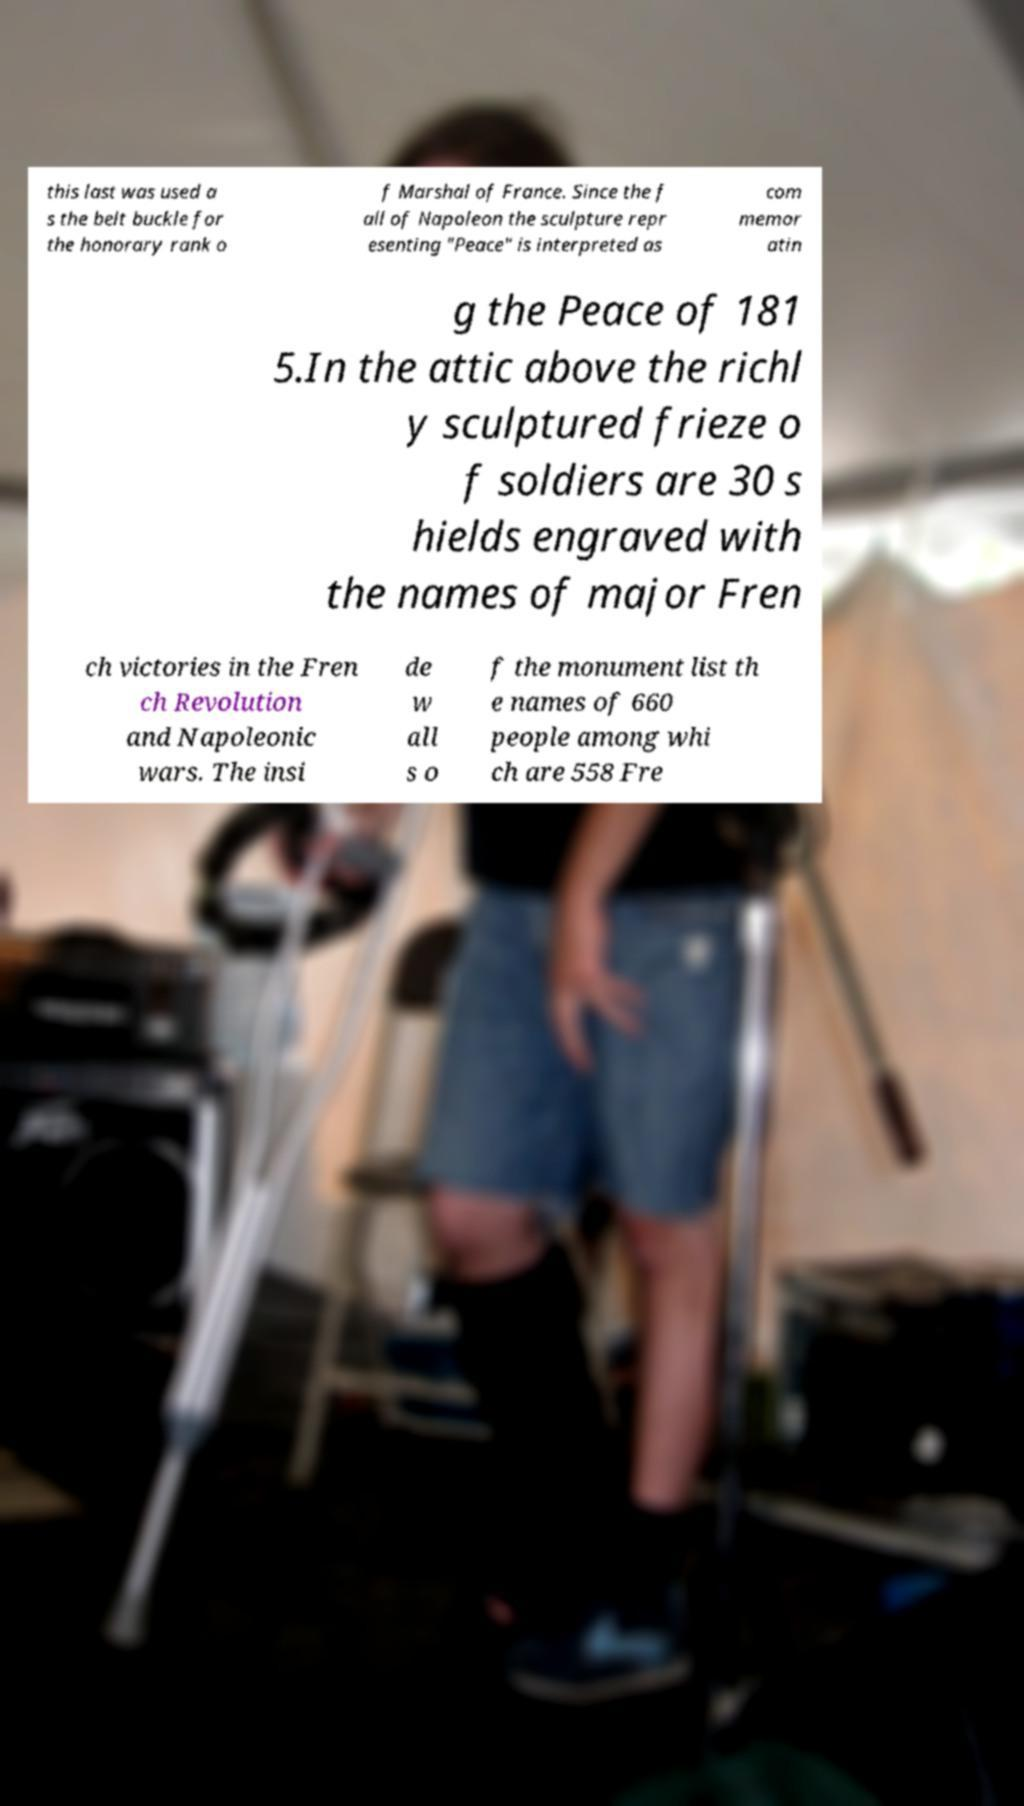Could you assist in decoding the text presented in this image and type it out clearly? this last was used a s the belt buckle for the honorary rank o f Marshal of France. Since the f all of Napoleon the sculpture repr esenting "Peace" is interpreted as com memor atin g the Peace of 181 5.In the attic above the richl y sculptured frieze o f soldiers are 30 s hields engraved with the names of major Fren ch victories in the Fren ch Revolution and Napoleonic wars. The insi de w all s o f the monument list th e names of 660 people among whi ch are 558 Fre 